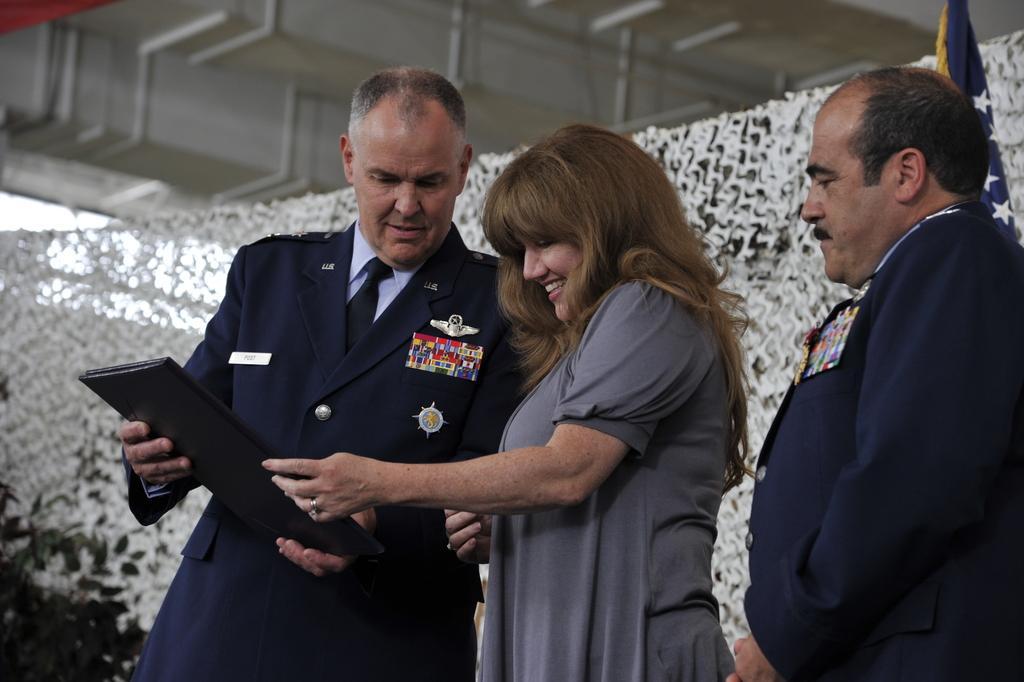Can you describe this image briefly? We can see a man and woman are standing and holding a book with their hands and on the right side a man is standing and there is a flag. In the background there is a plant, an object and pipes. 